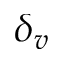<formula> <loc_0><loc_0><loc_500><loc_500>\delta _ { v }</formula> 